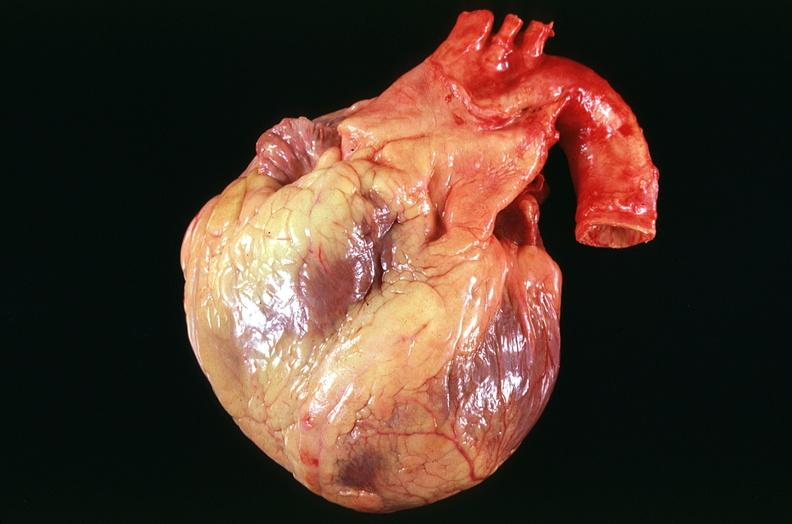where is this?
Answer the question using a single word or phrase. Heart 